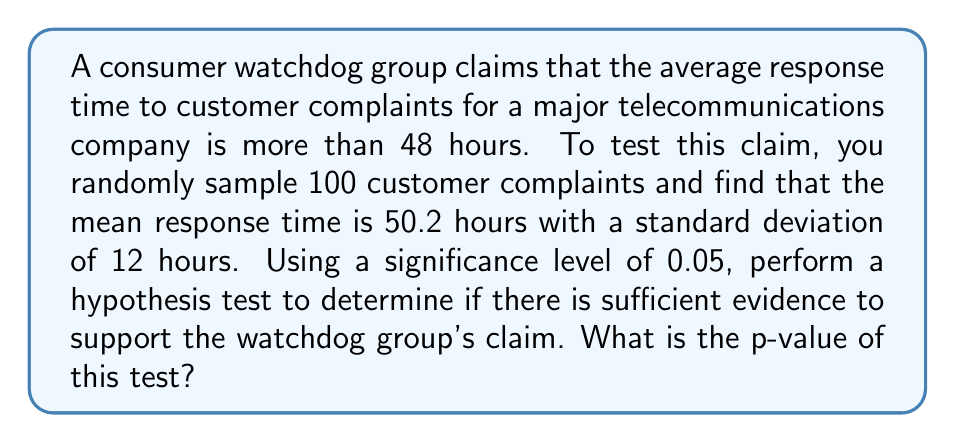What is the answer to this math problem? Let's approach this step-by-step:

1) First, we need to set up our hypotheses:
   $H_0: \mu \leq 48$ (null hypothesis)
   $H_a: \mu > 48$ (alternative hypothesis)

2) We're dealing with a one-tailed test since we're only interested if the mean is greater than 48 hours.

3) Given information:
   - Sample size: $n = 100$
   - Sample mean: $\bar{x} = 50.2$ hours
   - Sample standard deviation: $s = 12$ hours
   - Significance level: $\alpha = 0.05$

4) We'll use a t-test because we don't know the population standard deviation.

5) Calculate the t-statistic:
   $$t = \frac{\bar{x} - \mu_0}{s/\sqrt{n}} = \frac{50.2 - 48}{12/\sqrt{100}} = \frac{2.2}{1.2} = 1.833$$

6) Degrees of freedom: $df = n - 1 = 99$

7) To find the p-value, we need to determine the probability of observing a t-value greater than 1.833 with 99 degrees of freedom.

8) Using a t-distribution table or calculator, we find:
   $p-value = P(t > 1.833) \approx 0.0349$

9) Interpretation: Since the p-value (0.0349) is less than the significance level (0.05), we reject the null hypothesis.
Answer: 0.0349 